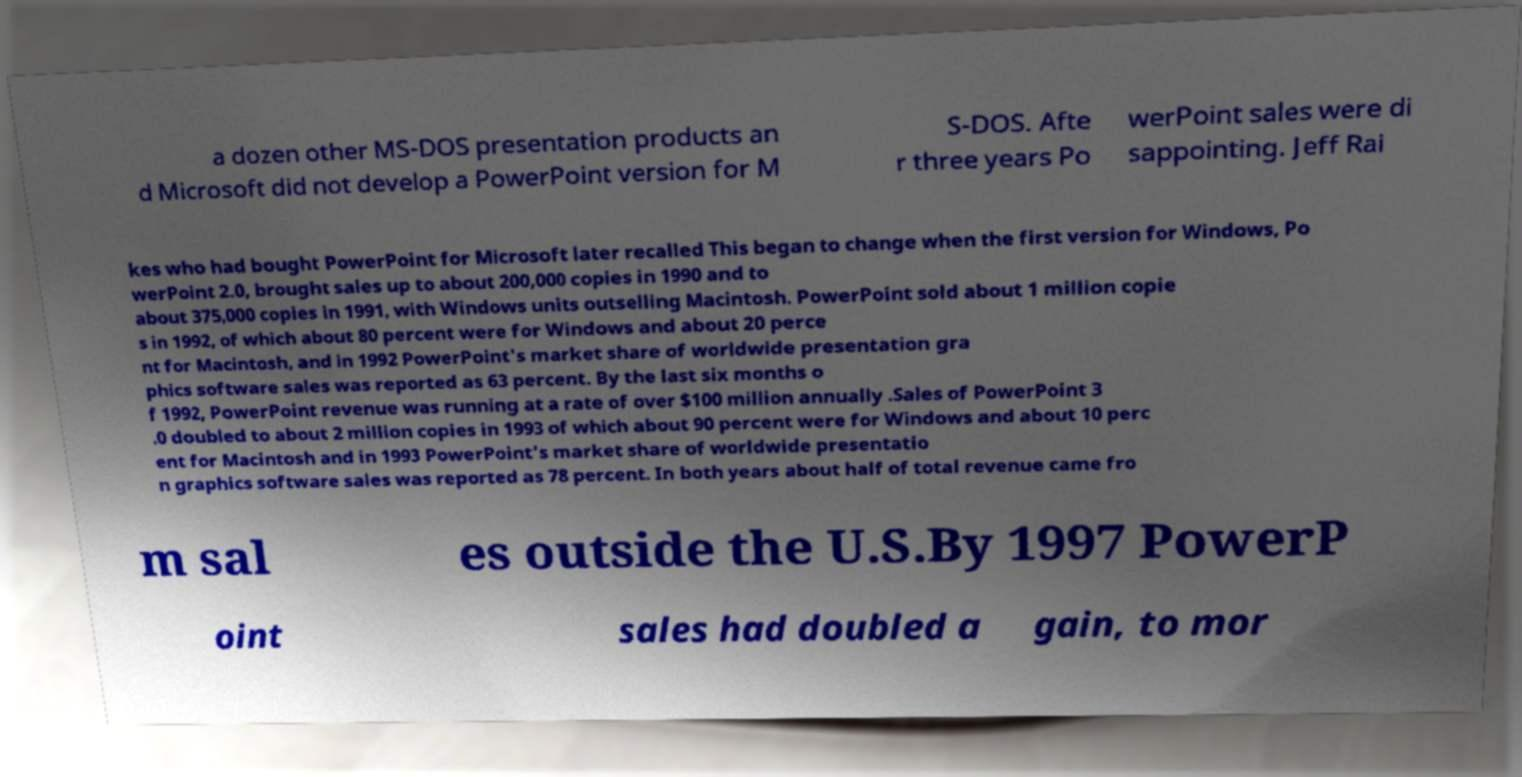Could you extract and type out the text from this image? a dozen other MS-DOS presentation products an d Microsoft did not develop a PowerPoint version for M S-DOS. Afte r three years Po werPoint sales were di sappointing. Jeff Rai kes who had bought PowerPoint for Microsoft later recalled This began to change when the first version for Windows, Po werPoint 2.0, brought sales up to about 200,000 copies in 1990 and to about 375,000 copies in 1991, with Windows units outselling Macintosh. PowerPoint sold about 1 million copie s in 1992, of which about 80 percent were for Windows and about 20 perce nt for Macintosh, and in 1992 PowerPoint's market share of worldwide presentation gra phics software sales was reported as 63 percent. By the last six months o f 1992, PowerPoint revenue was running at a rate of over $100 million annually .Sales of PowerPoint 3 .0 doubled to about 2 million copies in 1993 of which about 90 percent were for Windows and about 10 perc ent for Macintosh and in 1993 PowerPoint's market share of worldwide presentatio n graphics software sales was reported as 78 percent. In both years about half of total revenue came fro m sal es outside the U.S.By 1997 PowerP oint sales had doubled a gain, to mor 